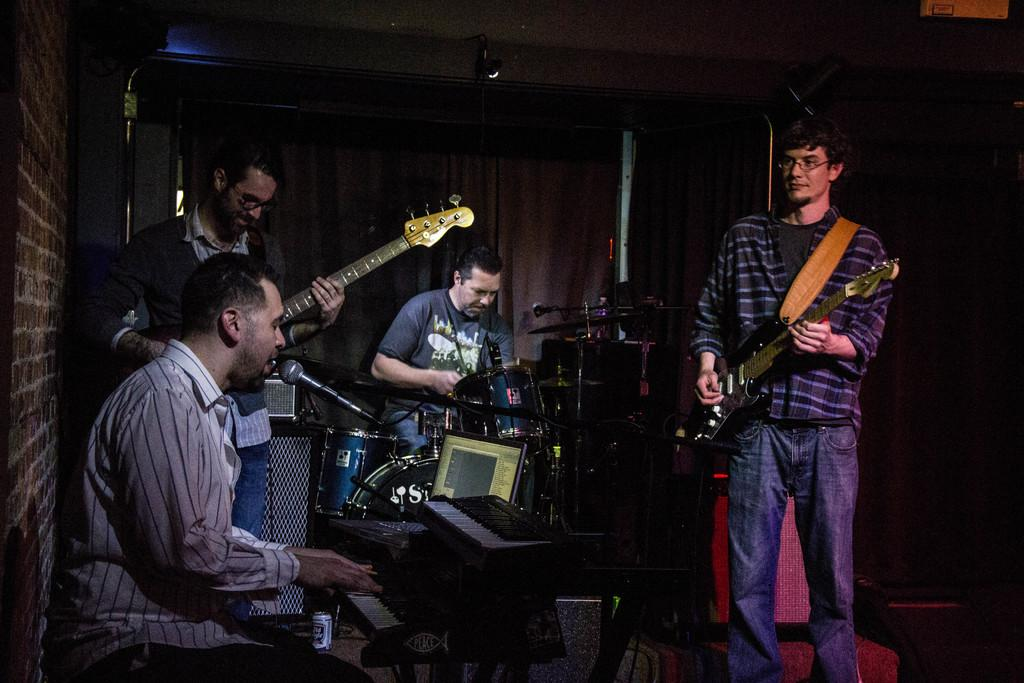What are the people in the image doing? The people in the image are playing musical instruments and singing together. What type of activity is the group engaged in? The group is engaged in a musical performance. How many people are involved in the activity? There is a group of persons in the image, but the exact number is not specified. What color is the pen used by the person playing the guitar in the image? There is no pen present in the image, as the people are playing musical instruments and singing together. 